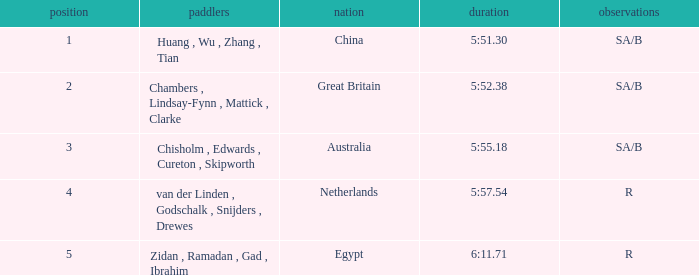What country has sa/b as the notes, and a time of 5:51.30? China. 